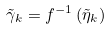<formula> <loc_0><loc_0><loc_500><loc_500>\tilde { \gamma } _ { k } = f ^ { - 1 } \left ( \tilde { \eta } _ { k } \right )</formula> 